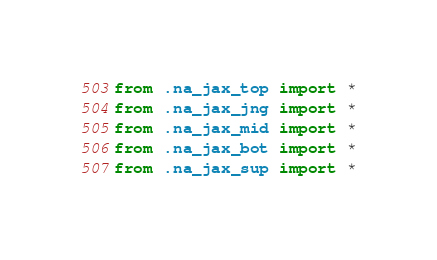<code> <loc_0><loc_0><loc_500><loc_500><_Python_>from .na_jax_top import *
from .na_jax_jng import *
from .na_jax_mid import *
from .na_jax_bot import *
from .na_jax_sup import *
</code> 